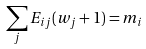Convert formula to latex. <formula><loc_0><loc_0><loc_500><loc_500>\sum _ { j } E _ { i j } ( w _ { j } + 1 ) = m _ { i }</formula> 